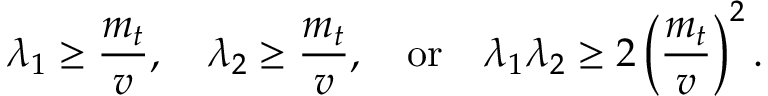Convert formula to latex. <formula><loc_0><loc_0><loc_500><loc_500>{ \lambda _ { 1 } } \geq { \frac { m _ { t } } { v } } , \quad \lambda _ { 2 } \geq { \frac { m _ { t } } { v } } , \quad o r \quad \lambda _ { 1 } \lambda _ { 2 } \geq { 2 } \left ( \frac { m _ { t } } { v } \right ) ^ { 2 } .</formula> 